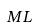Convert formula to latex. <formula><loc_0><loc_0><loc_500><loc_500>M L</formula> 